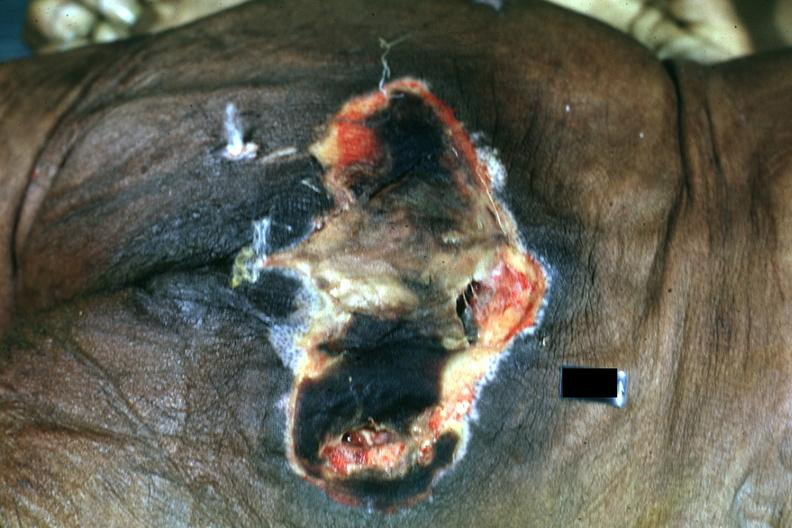s omentum present?
Answer the question using a single word or phrase. No 